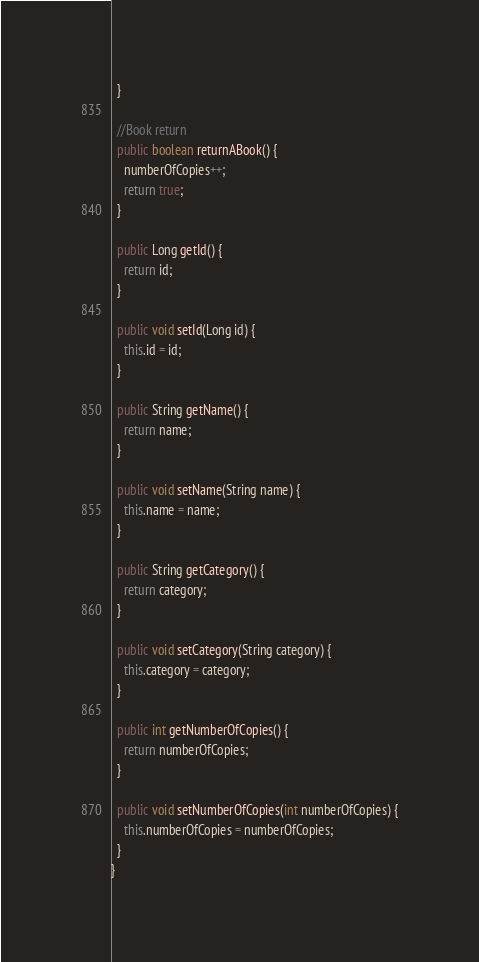Convert code to text. <code><loc_0><loc_0><loc_500><loc_500><_Java_>  }

  //Book return
  public boolean returnABook() {
    numberOfCopies++;
    return true;
  }

  public Long getId() {
    return id;
  }

  public void setId(Long id) {
    this.id = id;
  }

  public String getName() {
    return name;
  }

  public void setName(String name) {
    this.name = name;
  }

  public String getCategory() {
    return category;
  }

  public void setCategory(String category) {
    this.category = category;
  }

  public int getNumberOfCopies() {
    return numberOfCopies;
  }

  public void setNumberOfCopies(int numberOfCopies) {
    this.numberOfCopies = numberOfCopies;
  }
}
</code> 